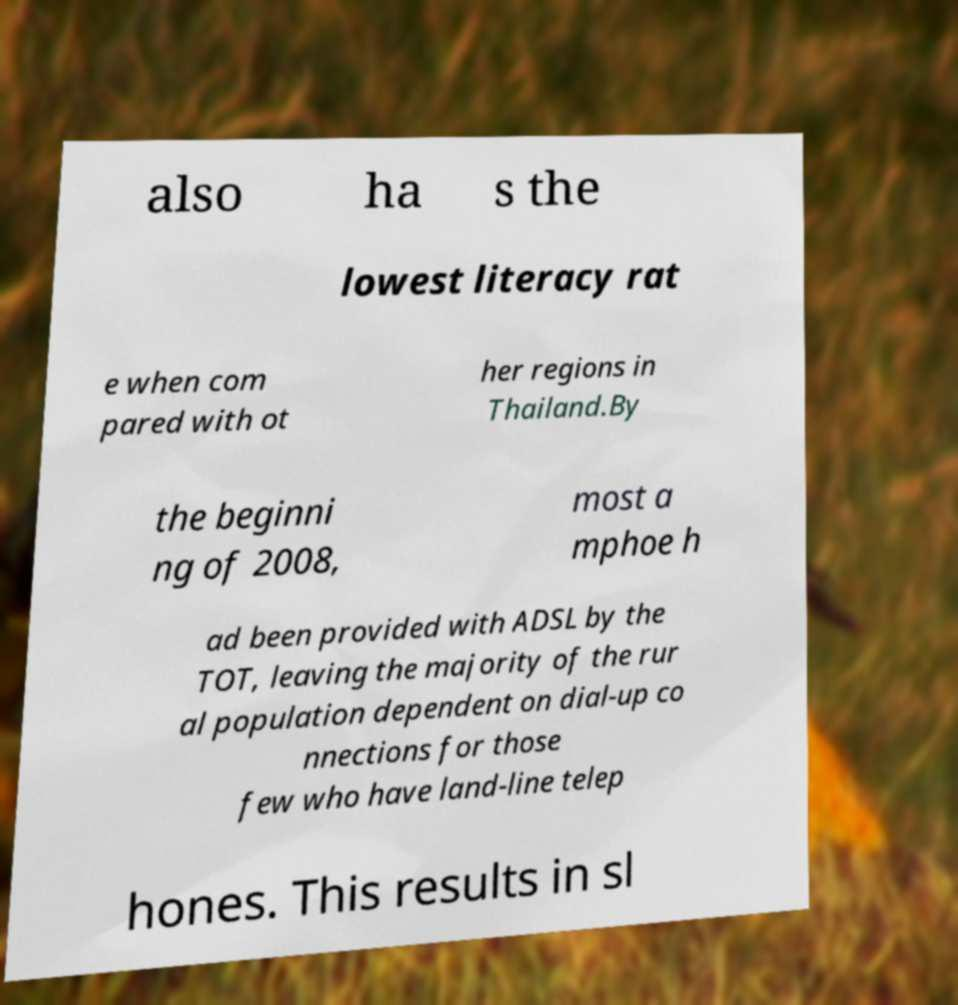Can you accurately transcribe the text from the provided image for me? also ha s the lowest literacy rat e when com pared with ot her regions in Thailand.By the beginni ng of 2008, most a mphoe h ad been provided with ADSL by the TOT, leaving the majority of the rur al population dependent on dial-up co nnections for those few who have land-line telep hones. This results in sl 